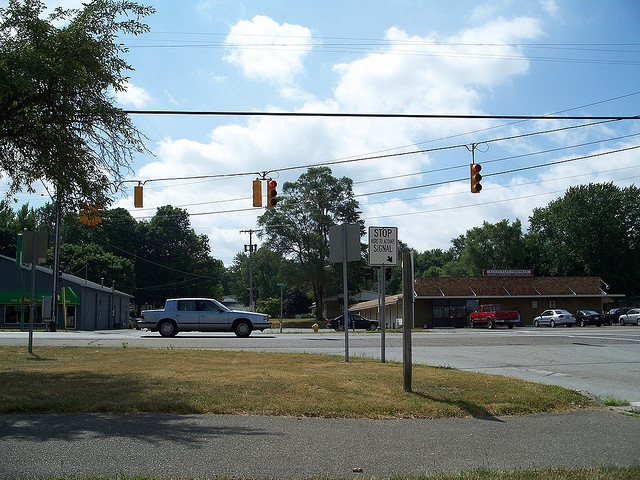Describe the objects in this image and their specific colors. I can see car in lightblue, black, darkblue, gray, and navy tones, truck in lightblue, black, maroon, gray, and brown tones, car in lightblue, black, gray, and lavender tones, car in lightblue, black, gray, and darkgray tones, and traffic light in lightblue, black, maroon, and gray tones in this image. 